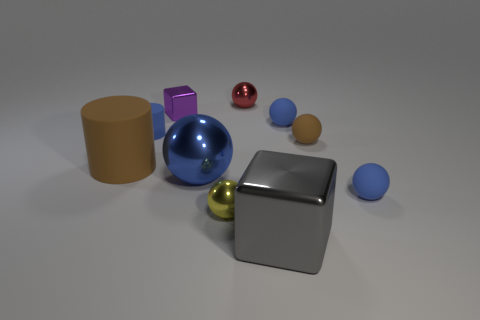Subtract all blue balls. How many were subtracted if there are1blue balls left? 2 Subtract all red blocks. How many blue balls are left? 3 Subtract 1 spheres. How many spheres are left? 5 Subtract all brown spheres. How many spheres are left? 5 Subtract all big shiny balls. How many balls are left? 5 Subtract all purple balls. Subtract all red cubes. How many balls are left? 6 Subtract all cubes. How many objects are left? 8 Add 5 brown rubber balls. How many brown rubber balls exist? 6 Subtract 0 yellow blocks. How many objects are left? 10 Subtract all big cyan things. Subtract all red shiny things. How many objects are left? 9 